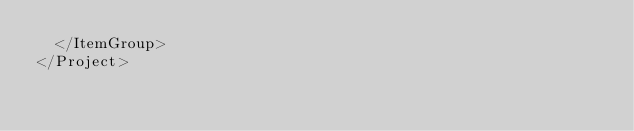Convert code to text. <code><loc_0><loc_0><loc_500><loc_500><_XML_>  </ItemGroup>
</Project>
</code> 